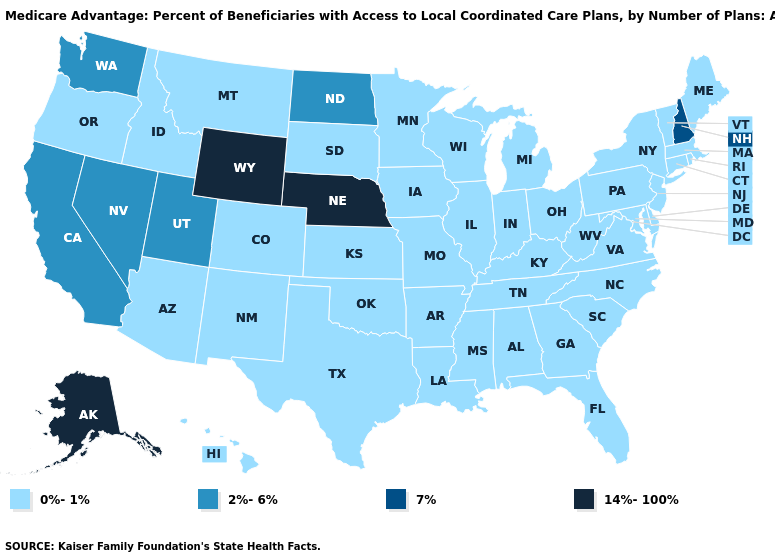Among the states that border Virginia , which have the highest value?
Give a very brief answer. Kentucky, Maryland, North Carolina, Tennessee, West Virginia. Which states hav the highest value in the West?
Answer briefly. Alaska, Wyoming. Does Vermont have a higher value than South Dakota?
Quick response, please. No. What is the value of Idaho?
Give a very brief answer. 0%-1%. What is the value of Maryland?
Keep it brief. 0%-1%. Does Maryland have a lower value than Alaska?
Concise answer only. Yes. What is the lowest value in the Northeast?
Write a very short answer. 0%-1%. What is the highest value in the Northeast ?
Keep it brief. 7%. What is the value of New Mexico?
Answer briefly. 0%-1%. Among the states that border Delaware , which have the highest value?
Short answer required. Maryland, New Jersey, Pennsylvania. Name the states that have a value in the range 2%-6%?
Be succinct. California, North Dakota, Nevada, Utah, Washington. What is the lowest value in the USA?
Quick response, please. 0%-1%. What is the value of Hawaii?
Be succinct. 0%-1%. 